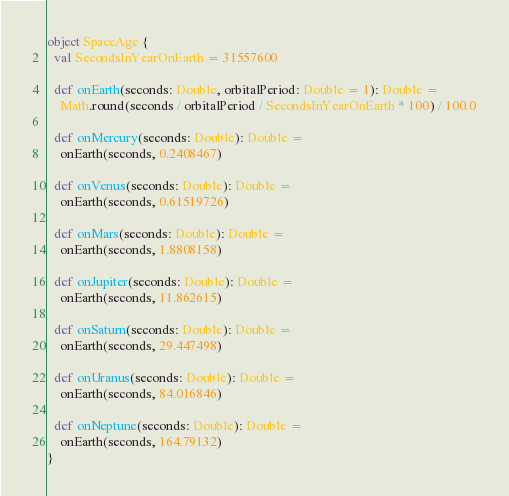Convert code to text. <code><loc_0><loc_0><loc_500><loc_500><_Scala_>object SpaceAge {
  val SecondsInYearOnEarth = 31557600

  def onEarth(seconds: Double, orbitalPeriod: Double = 1): Double =
    Math.round(seconds / orbitalPeriod / SecondsInYearOnEarth * 100) / 100.0

  def onMercury(seconds: Double): Double =
    onEarth(seconds, 0.2408467)

  def onVenus(seconds: Double): Double =
    onEarth(seconds, 0.61519726)

  def onMars(seconds: Double): Double =
    onEarth(seconds, 1.8808158)

  def onJupiter(seconds: Double): Double =
    onEarth(seconds, 11.862615)

  def onSaturn(seconds: Double): Double =
    onEarth(seconds, 29.447498)

  def onUranus(seconds: Double): Double =
    onEarth(seconds, 84.016846)

  def onNeptune(seconds: Double): Double =
    onEarth(seconds, 164.79132)
}</code> 